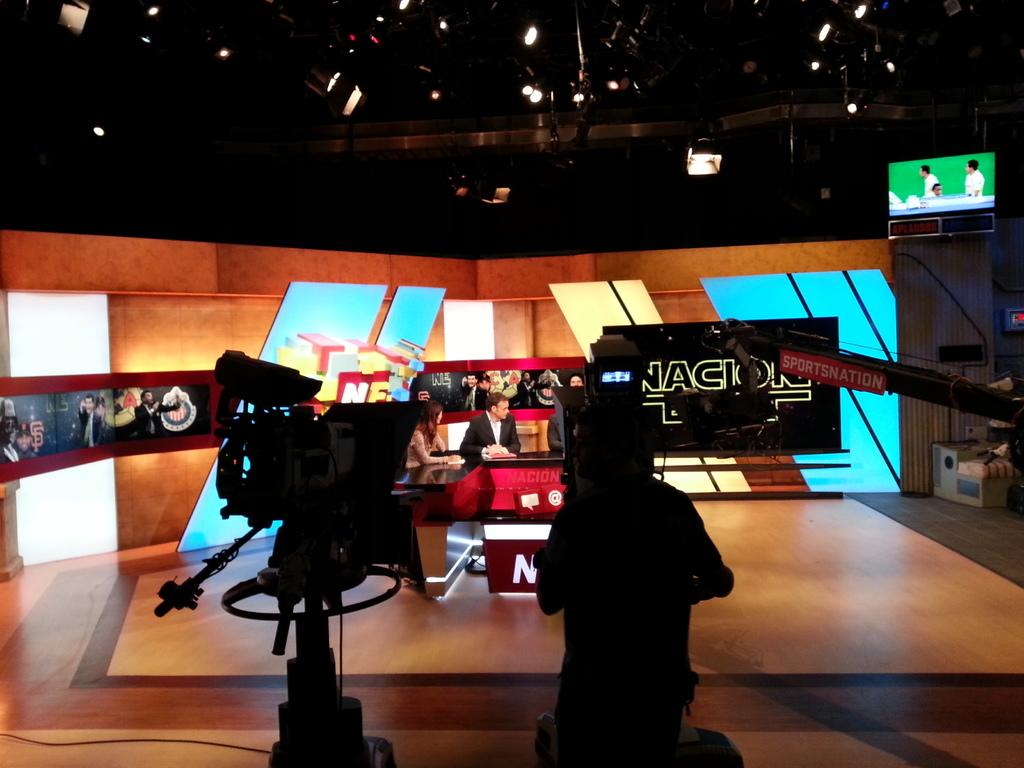What is this show?
Offer a very short reply. Sportsnation. 